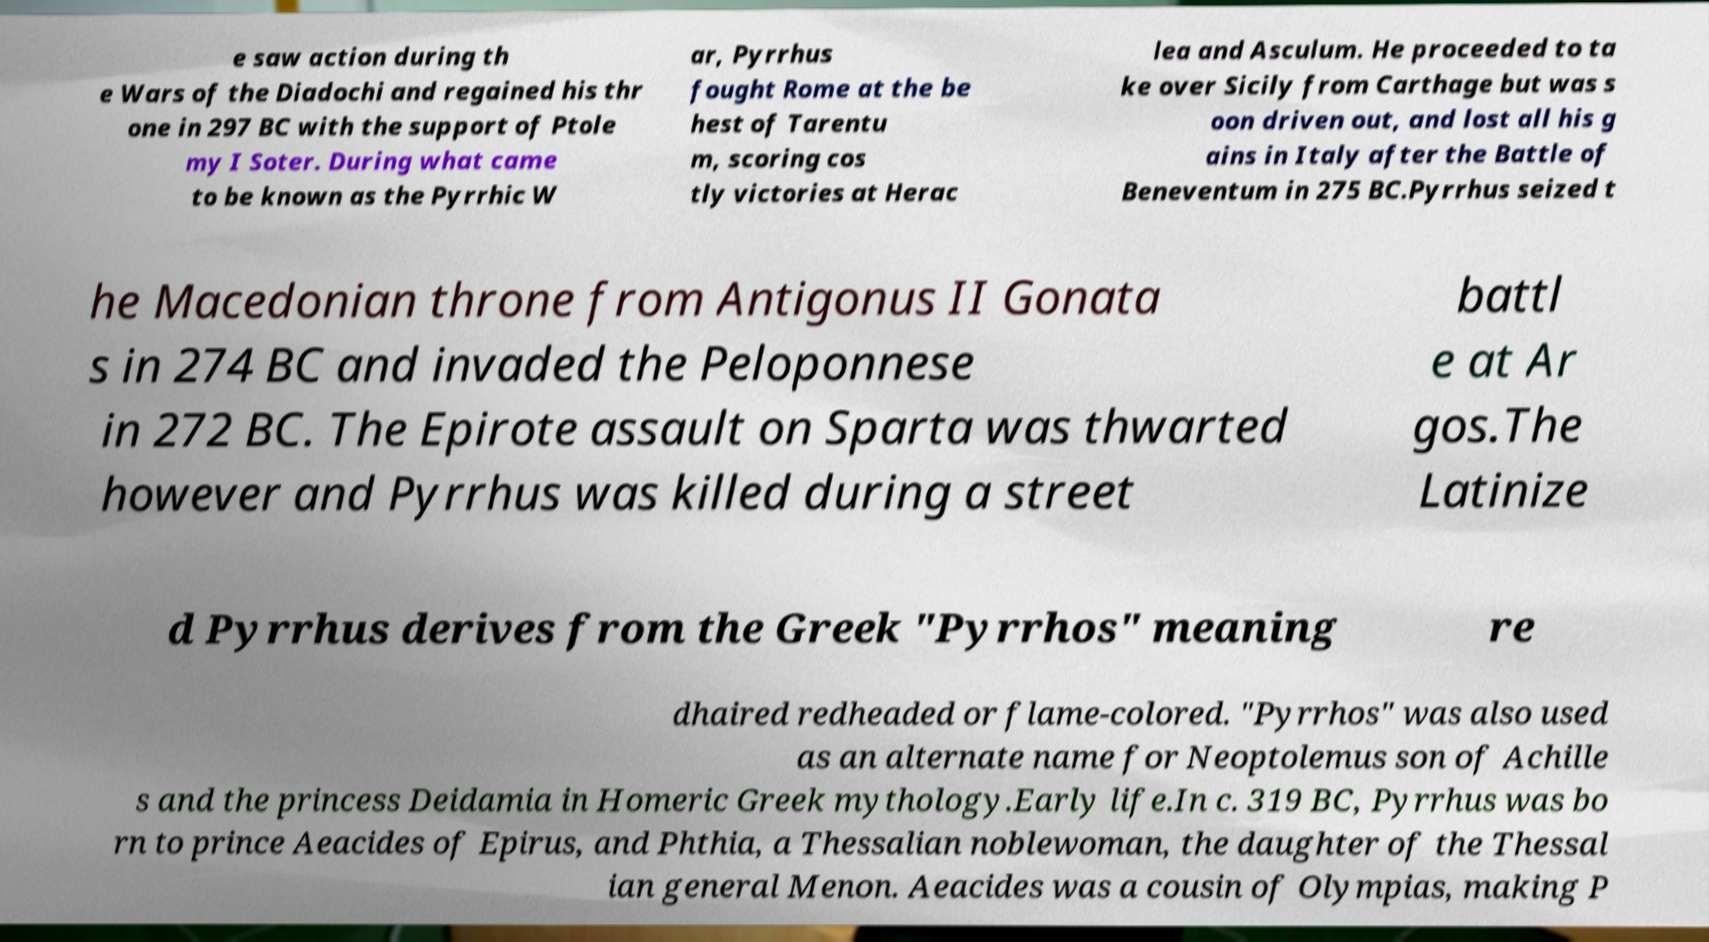Please identify and transcribe the text found in this image. e saw action during th e Wars of the Diadochi and regained his thr one in 297 BC with the support of Ptole my I Soter. During what came to be known as the Pyrrhic W ar, Pyrrhus fought Rome at the be hest of Tarentu m, scoring cos tly victories at Herac lea and Asculum. He proceeded to ta ke over Sicily from Carthage but was s oon driven out, and lost all his g ains in Italy after the Battle of Beneventum in 275 BC.Pyrrhus seized t he Macedonian throne from Antigonus II Gonata s in 274 BC and invaded the Peloponnese in 272 BC. The Epirote assault on Sparta was thwarted however and Pyrrhus was killed during a street battl e at Ar gos.The Latinize d Pyrrhus derives from the Greek "Pyrrhos" meaning re dhaired redheaded or flame-colored. "Pyrrhos" was also used as an alternate name for Neoptolemus son of Achille s and the princess Deidamia in Homeric Greek mythology.Early life.In c. 319 BC, Pyrrhus was bo rn to prince Aeacides of Epirus, and Phthia, a Thessalian noblewoman, the daughter of the Thessal ian general Menon. Aeacides was a cousin of Olympias, making P 